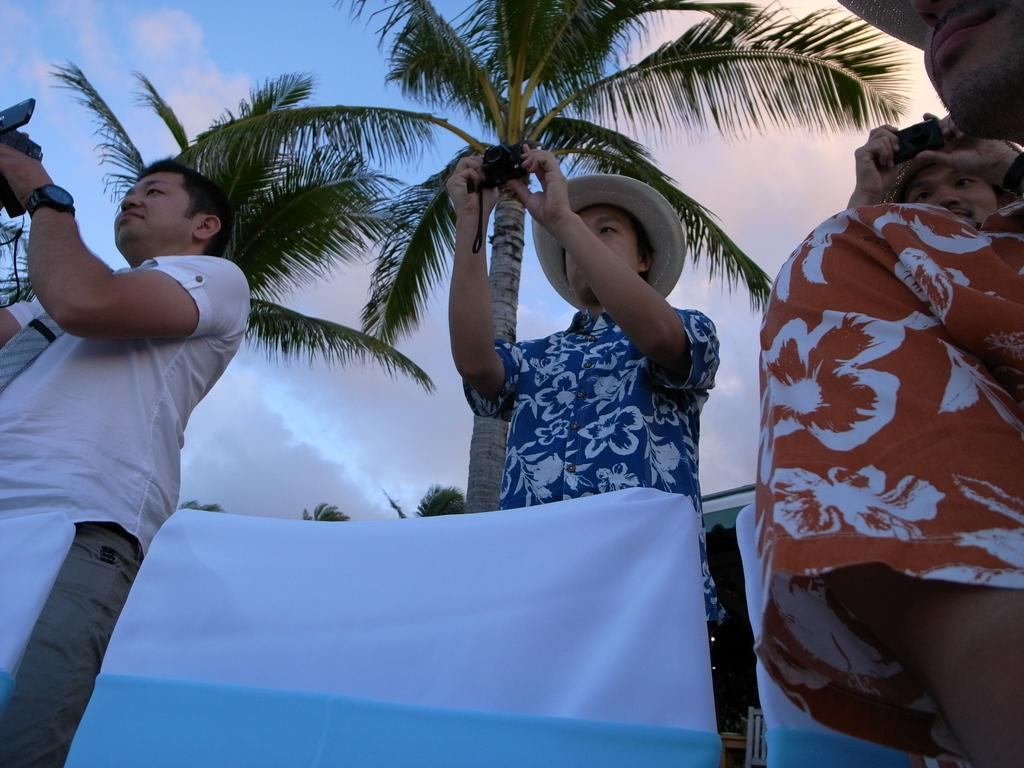What are the people in the center of the image doing? The people in the center of the image are standing and holding a camera. What else can be seen in the image besides the people with the camera? There are other objects visible in the image. What is visible in the background of the image? The sky, clouds, and trees are visible in the background of the image. What type of clock is hanging on the tree in the image? There is no clock present in the image, and no clock is mentioned in the provided facts. 